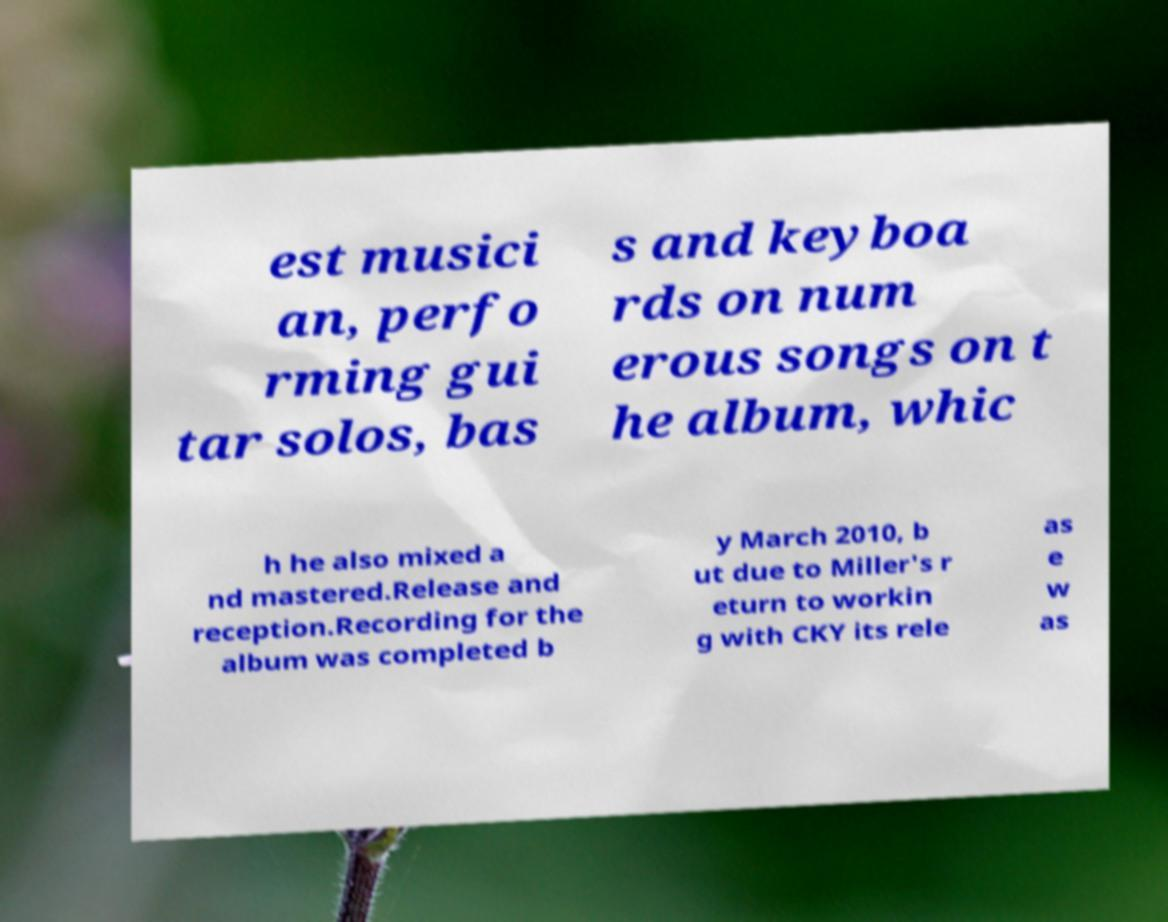For documentation purposes, I need the text within this image transcribed. Could you provide that? est musici an, perfo rming gui tar solos, bas s and keyboa rds on num erous songs on t he album, whic h he also mixed a nd mastered.Release and reception.Recording for the album was completed b y March 2010, b ut due to Miller's r eturn to workin g with CKY its rele as e w as 